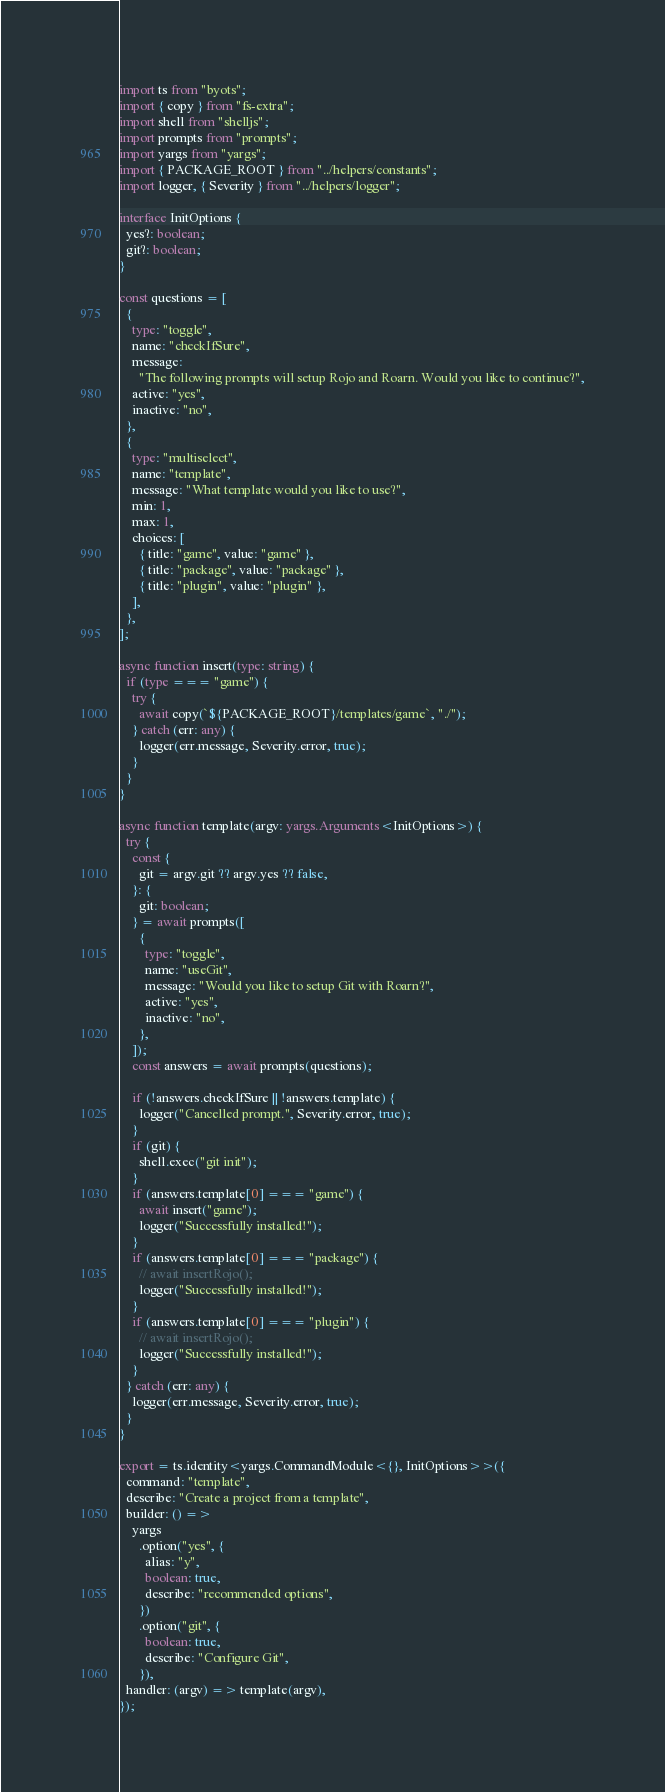Convert code to text. <code><loc_0><loc_0><loc_500><loc_500><_TypeScript_>import ts from "byots";
import { copy } from "fs-extra";
import shell from "shelljs";
import prompts from "prompts";
import yargs from "yargs";
import { PACKAGE_ROOT } from "../helpers/constants";
import logger, { Severity } from "../helpers/logger";

interface InitOptions {
  yes?: boolean;
  git?: boolean;
}

const questions = [
  {
    type: "toggle",
    name: "checkIfSure",
    message:
      "The following prompts will setup Rojo and Roarn. Would you like to continue?",
    active: "yes",
    inactive: "no",
  },
  {
    type: "multiselect",
    name: "template",
    message: "What template would you like to use?",
    min: 1,
    max: 1,
    choices: [
      { title: "game", value: "game" },
      { title: "package", value: "package" },
      { title: "plugin", value: "plugin" },
    ],
  },
];

async function insert(type: string) {
  if (type === "game") {
    try {
      await copy(`${PACKAGE_ROOT}/templates/game`, "./");
    } catch (err: any) {
      logger(err.message, Severity.error, true);
    }
  }
}

async function template(argv: yargs.Arguments<InitOptions>) {
  try {
    const {
      git = argv.git ?? argv.yes ?? false,
    }: {
      git: boolean;
    } = await prompts([
      {
        type: "toggle",
        name: "useGit",
        message: "Would you like to setup Git with Roarn?",
        active: "yes",
        inactive: "no",
      },
    ]);
    const answers = await prompts(questions);

    if (!answers.checkIfSure || !answers.template) {
      logger("Cancelled prompt.", Severity.error, true);
    }
    if (git) {
      shell.exec("git init");
    }
    if (answers.template[0] === "game") {
      await insert("game");
      logger("Successfully installed!");
    }
    if (answers.template[0] === "package") {
      // await insertRojo();
      logger("Successfully installed!");
    }
    if (answers.template[0] === "plugin") {
      // await insertRojo();
      logger("Successfully installed!");
    }
  } catch (err: any) {
    logger(err.message, Severity.error, true);
  }
}

export = ts.identity<yargs.CommandModule<{}, InitOptions>>({
  command: "template",
  describe: "Create a project from a template",
  builder: () =>
    yargs
      .option("yes", {
        alias: "y",
        boolean: true,
        describe: "recommended options",
      })
      .option("git", {
        boolean: true,
        describe: "Configure Git",
      }),
  handler: (argv) => template(argv),
});
</code> 